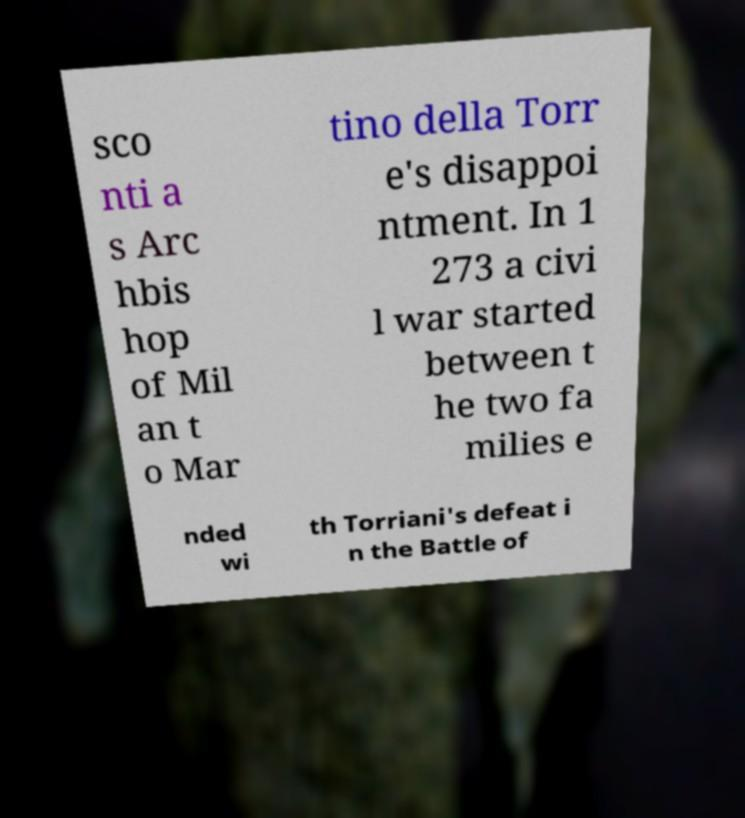Could you extract and type out the text from this image? sco nti a s Arc hbis hop of Mil an t o Mar tino della Torr e's disappoi ntment. In 1 273 a civi l war started between t he two fa milies e nded wi th Torriani's defeat i n the Battle of 